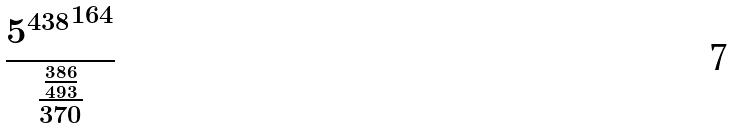<formula> <loc_0><loc_0><loc_500><loc_500>\frac { { 5 ^ { 4 3 8 } } ^ { 1 6 4 } } { \frac { \frac { 3 8 6 } { 4 9 3 } } { 3 7 0 } }</formula> 